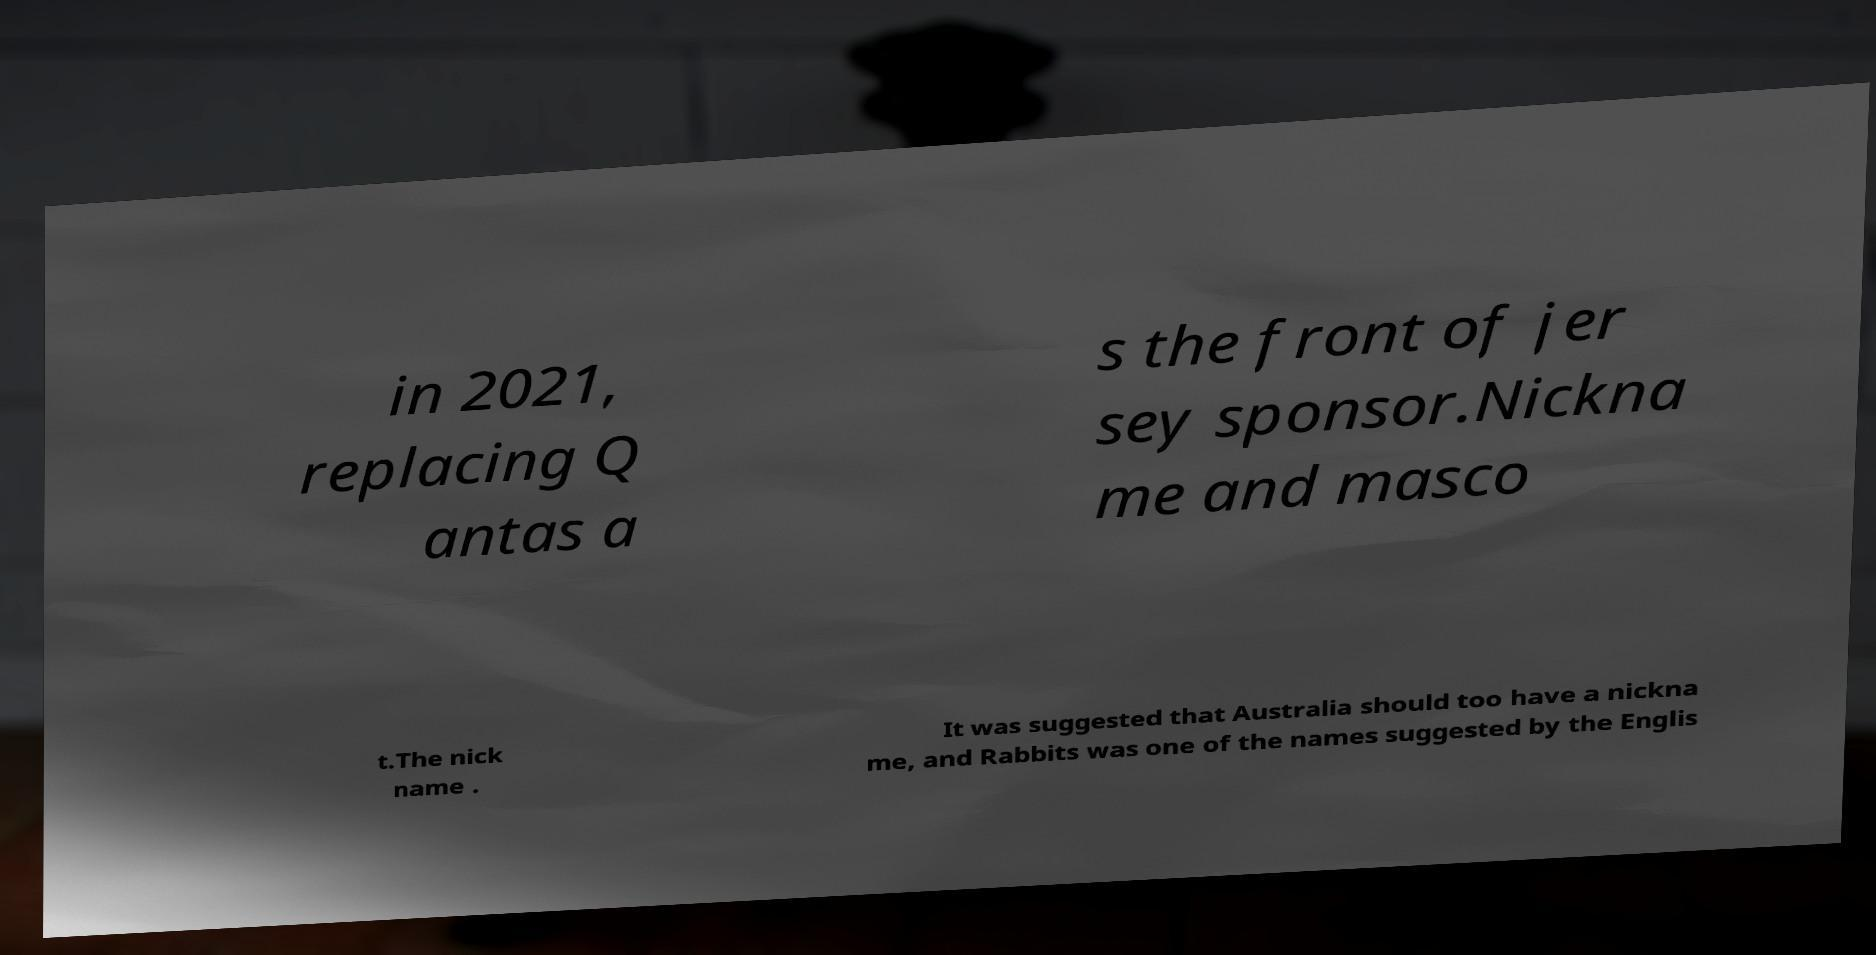Please read and relay the text visible in this image. What does it say? in 2021, replacing Q antas a s the front of jer sey sponsor.Nickna me and masco t.The nick name . It was suggested that Australia should too have a nickna me, and Rabbits was one of the names suggested by the Englis 